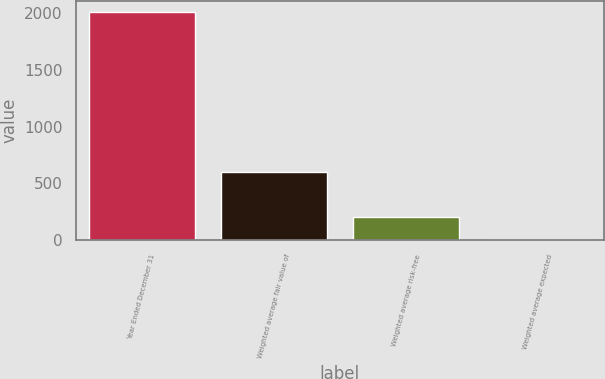<chart> <loc_0><loc_0><loc_500><loc_500><bar_chart><fcel>Year Ended December 31<fcel>Weighted average fair value of<fcel>Weighted average risk-free<fcel>Weighted average expected<nl><fcel>2007<fcel>604.73<fcel>204.09<fcel>3.77<nl></chart> 